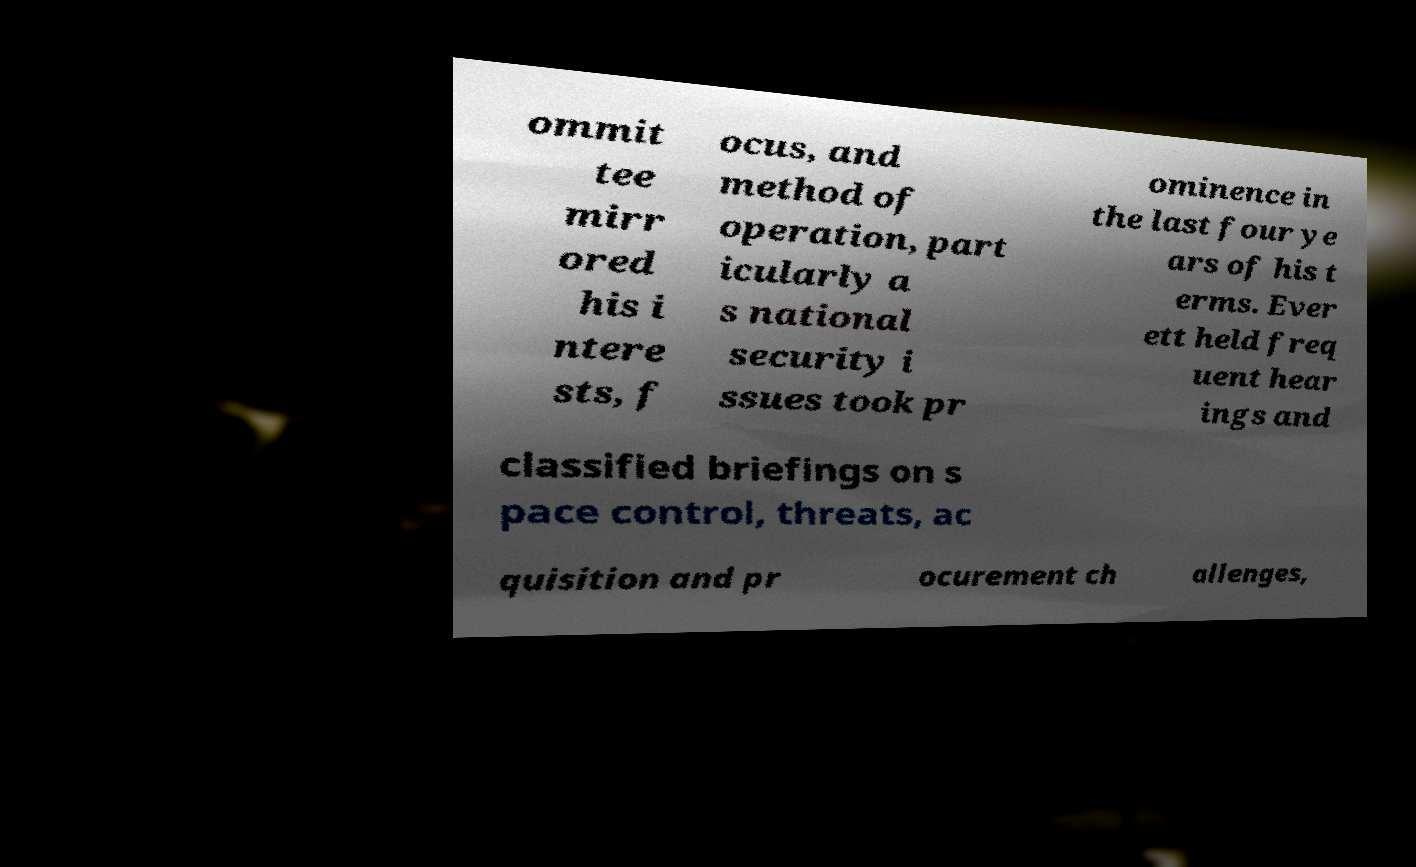Can you read and provide the text displayed in the image?This photo seems to have some interesting text. Can you extract and type it out for me? ommit tee mirr ored his i ntere sts, f ocus, and method of operation, part icularly a s national security i ssues took pr ominence in the last four ye ars of his t erms. Ever ett held freq uent hear ings and classified briefings on s pace control, threats, ac quisition and pr ocurement ch allenges, 